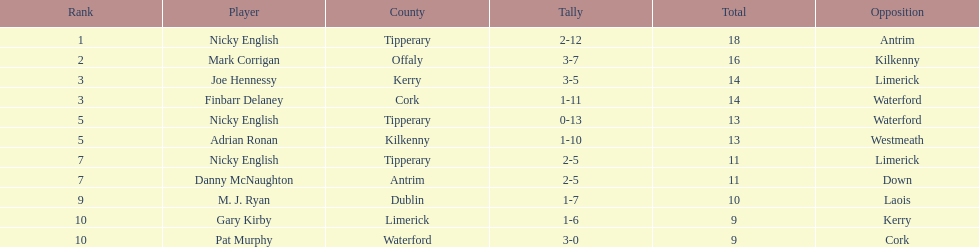Which player ranked the most? Nicky English. 